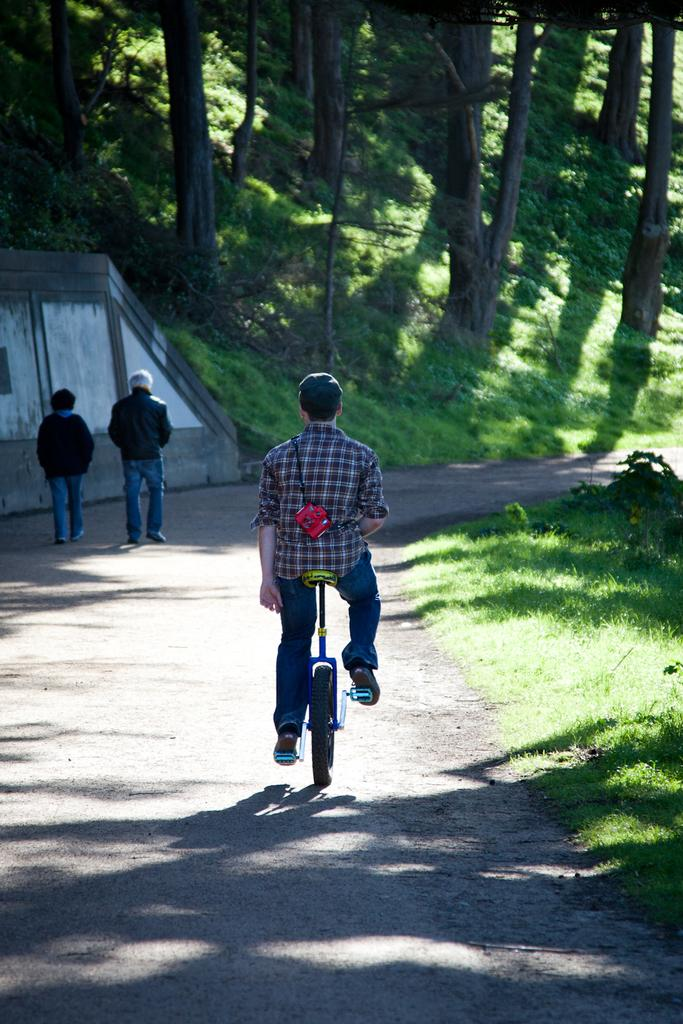What is the man in the image doing? The man is riding a bicycle in the image. What are the other people in the image doing? There is a man walking and a woman walking in the image. What can be seen in the background of the image? Trees are visible in the image. What type of ground surface is present in the image? There is grass on the ground in the image. What type of mitten is the man wearing while riding the bicycle in the image? There is no mitten visible in the image, as the man is riding a bicycle and not wearing any gloves or mittens. 